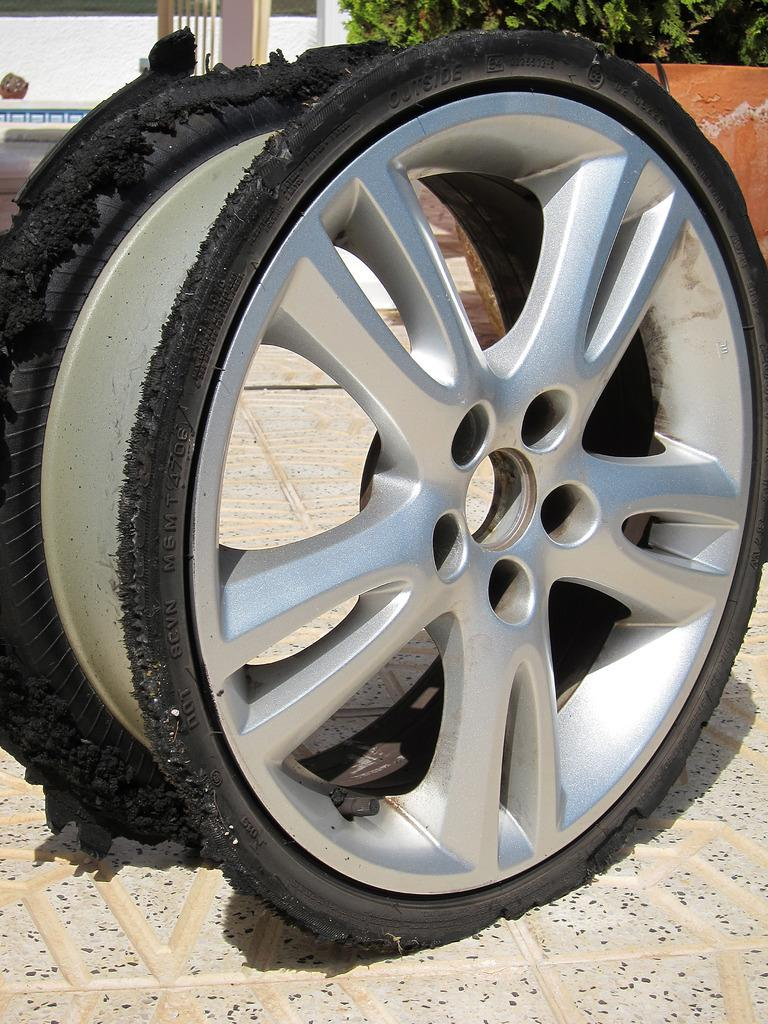What is located on the floor in the foreground of the image? There is a rim on the floor in the foreground of the image. What can be seen in the background of the image? There is a tree and a wall in the background of the image. Are there any other objects visible in the background of the image? Yes, there are other objects visible in the background of the image. What type of watch is hanging from the tree in the image? There is no watch present in the image; it features a tree, a wall, and other objects in the background, but no watch. 